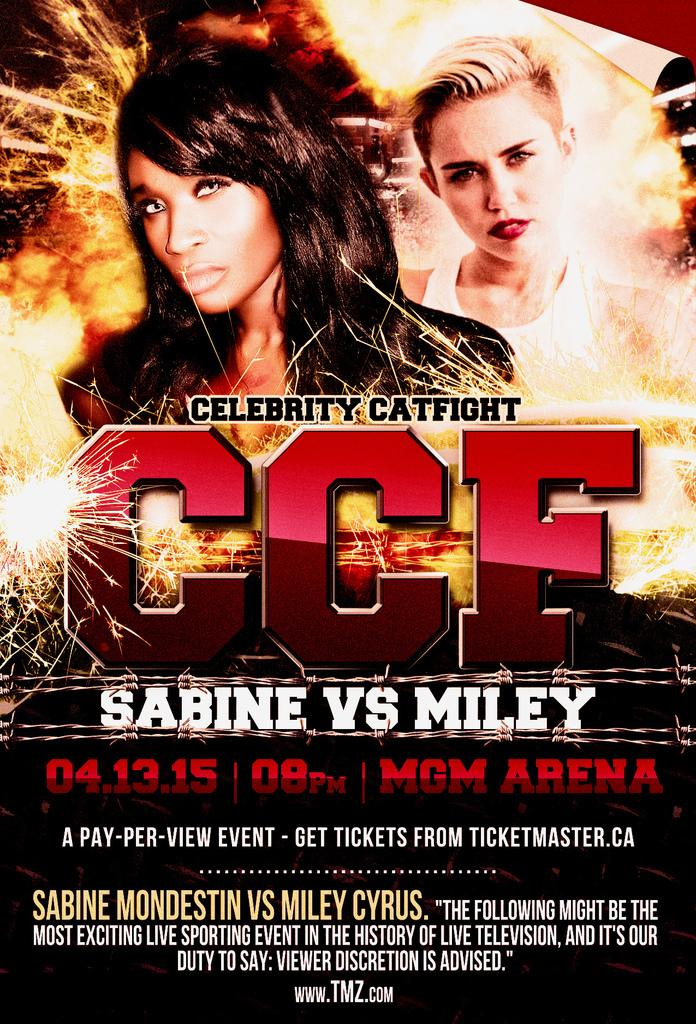Provide a one-sentence caption for the provided image. An advertisement for the Sabine Vs. Miley celebrity catfight. 